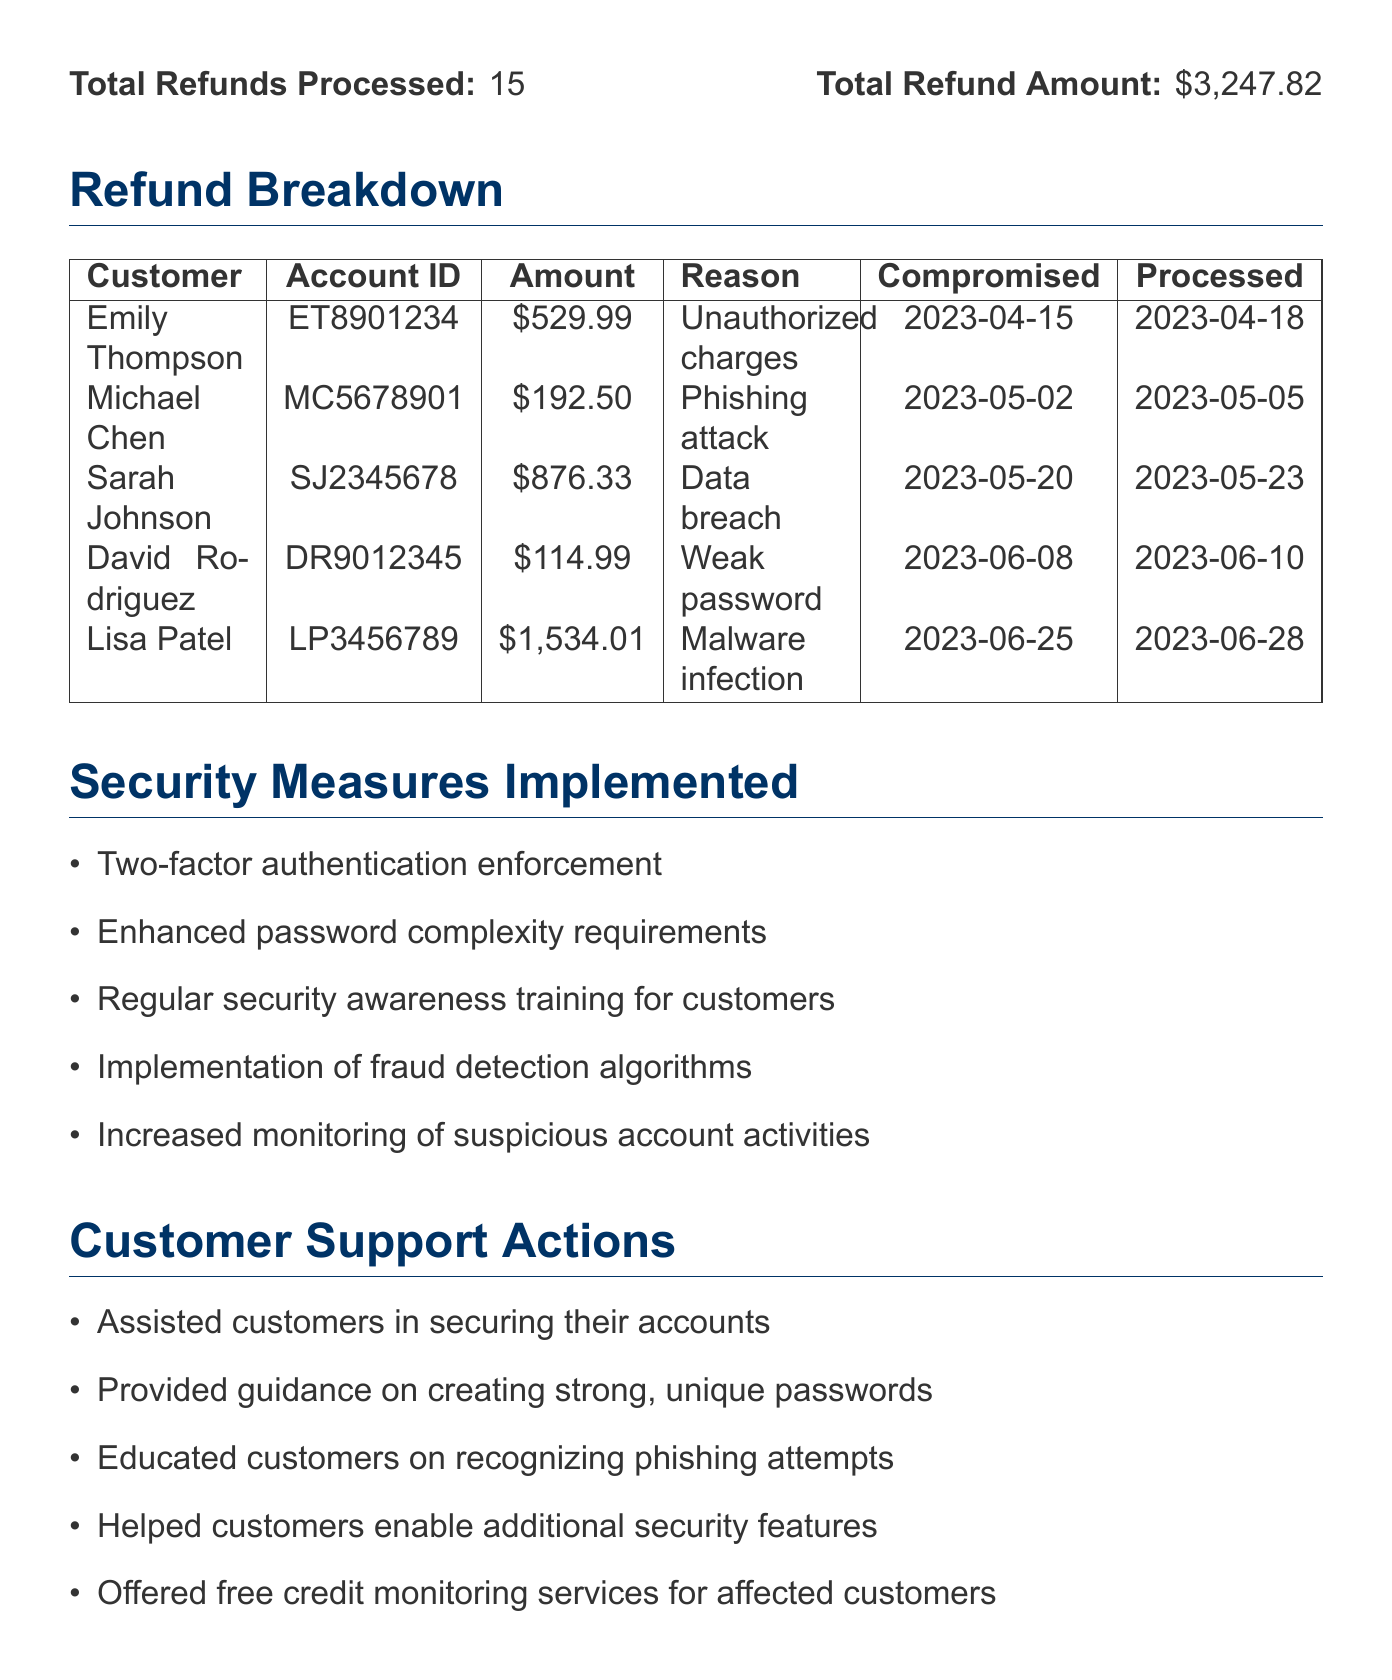What is the document title? The document title is clearly stated at the top of the report, which is "Refund Report for Compromised Accounts."
Answer: Refund Report for Compromised Accounts What is the total refund amount? The total refund amount is provided in the summary section, which states a total of $3,247.82.
Answer: $3,247.82 How many refunds were processed? The number of refunds processed is mentioned next to the total refund amount, which is 15.
Answer: 15 What is the reason for Sarah Johnson's refund? The reason is listed in the refund breakdown as "Data breach exposing personal information."
Answer: Data breach exposing personal information On what date was Lisa Patel's refund processed? The processed date for Lisa Patel's refund is given in the breakdown as "2023-06-28."
Answer: 2023-06-28 What security measure was enforced? One of the implemented security measures is listed as "Two-factor authentication enforcement."
Answer: Two-factor authentication enforcement What is one of the customer support actions taken? One of the actions is mentioned as "Assisted customers in securing their accounts."
Answer: Assisted customers in securing their accounts When did the refund policy update become effective? The effective date of the refund policy update is specified as "2023-07-01."
Answer: 2023-07-01 What is one of the next steps outlined in the document? The document mentions a next step as "Conduct a comprehensive security audit."
Answer: Conduct a comprehensive security audit 